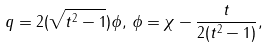Convert formula to latex. <formula><loc_0><loc_0><loc_500><loc_500>q = 2 ( \sqrt { t ^ { 2 } - 1 } ) \phi , \, \phi = \chi - \frac { t } { 2 ( t ^ { 2 } - 1 ) } ,</formula> 